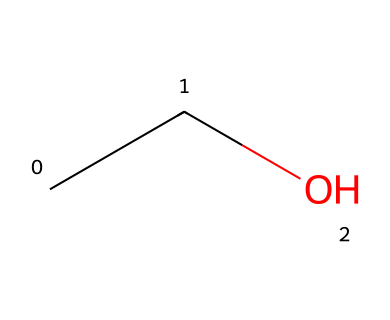What is the molecular formula of the compound represented by the SMILES? The SMILES representation "CCO" indicates that the compound consists of carbon (C) and oxygen (O) atoms. Counting the characters gives us two carbon atoms and one oxygen atom, leading to the molecular formula C2H6O.
Answer: C2H6O How many hydrogen atoms are present in this molecule? In the SMILES representation "CCO," each carbon generally forms four bonds. Here, the two carbons are connected to each other and to one oxygen. The missing hydrogen atoms are attached to each carbon atom. There are a total of six hydrogens based on the structure.
Answer: 6 What type of chemical is this compound? The compound represented by the SMILES "CCO" is an alcohol, as it contains a hydroxyl (OH) group connected to a carbon atom. This classification is standard in organic chemistry for such compounds.
Answer: alcohol What functional group is present in this molecule? The representation "CCO" shows a hydroxyl (-OH) group, which is characteristic of alcohols. This functional group is responsible for the solubility and properties of ethanol as a solvent.
Answer: hydroxyl Why is this molecule effective as a solvent? Ethanol has both hydrophilic (water-attracting due to the -OH group) and hydrophobic (carbon chains) properties, making it an effective solvent for a variety of substances, particularly polar compounds. The presence of the -OH group allows it to dissolve ionic and polar molecules.
Answer: effective solvent 